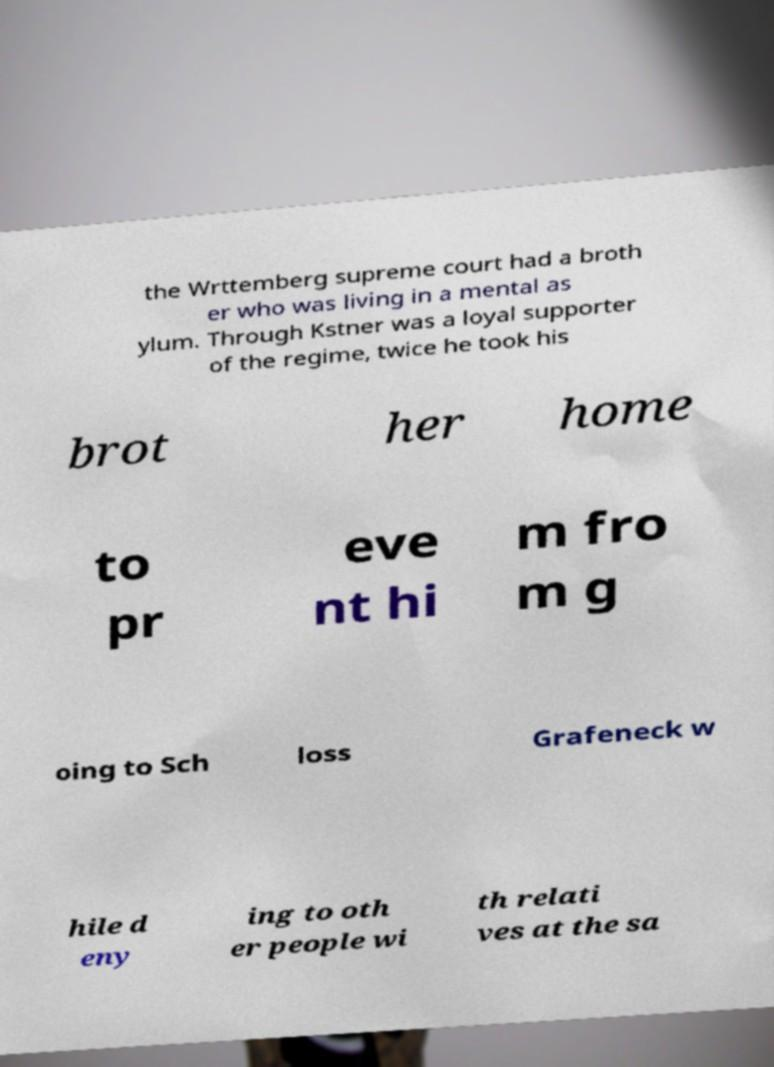What messages or text are displayed in this image? I need them in a readable, typed format. the Wrttemberg supreme court had a broth er who was living in a mental as ylum. Through Kstner was a loyal supporter of the regime, twice he took his brot her home to pr eve nt hi m fro m g oing to Sch loss Grafeneck w hile d eny ing to oth er people wi th relati ves at the sa 